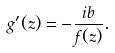Convert formula to latex. <formula><loc_0><loc_0><loc_500><loc_500>g ^ { \prime } ( z ) = - \frac { i b } { f ( z ) } .</formula> 